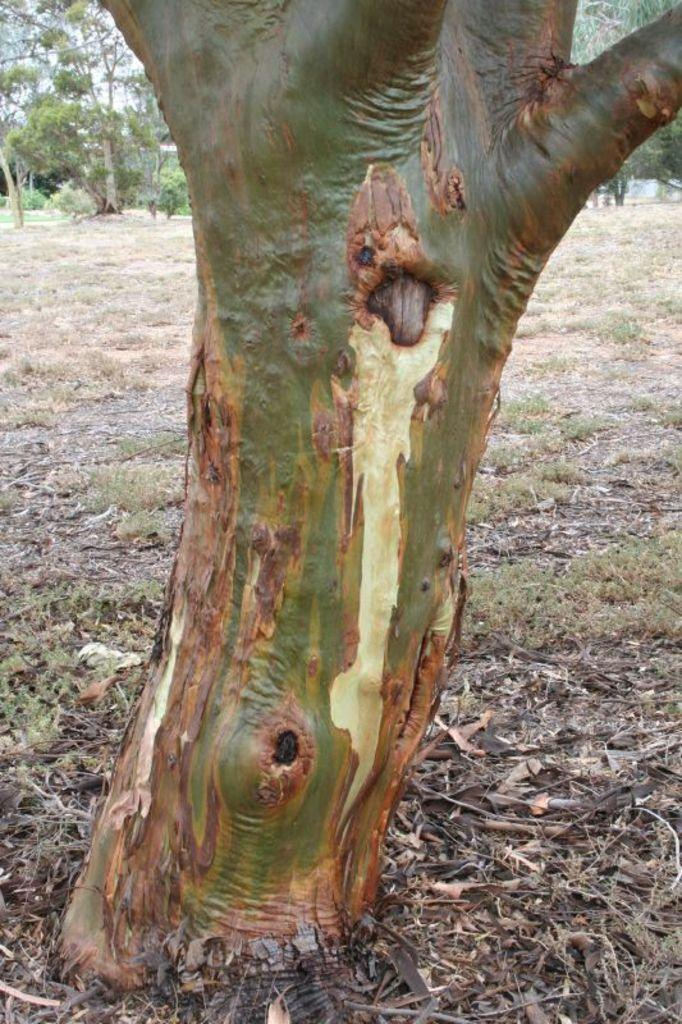What type of natural material is visible in the image? The image contains the bark of a tree and dried leaves. What type of vegetation is present in the image? Grass is present in the image. How many trees are visible in the image? There is a group of trees in the image. What is visible in the background of the image? The sky is visible in the image. What type of shirt is being worn by the tree in the image? There is no shirt present in the image, as it features natural elements such as tree bark, dried leaves, grass, and trees. 